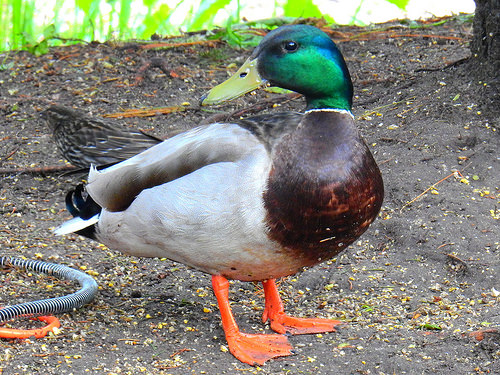<image>
Is the hose on the duck? No. The hose is not positioned on the duck. They may be near each other, but the hose is not supported by or resting on top of the duck. 